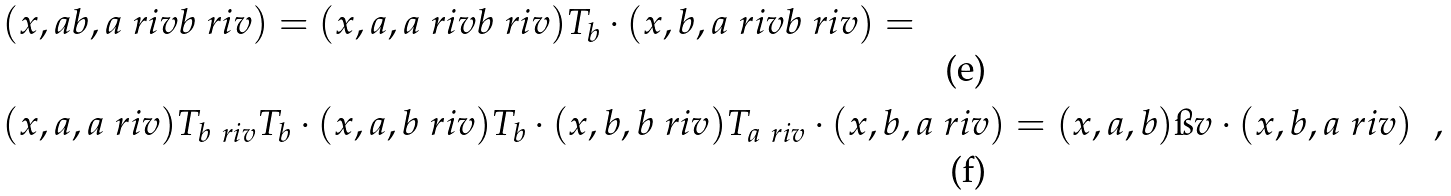Convert formula to latex. <formula><loc_0><loc_0><loc_500><loc_500>& ( x , a b , a \ r i v b \ r i v ) = ( x , a , a \ r i v b \ r i v ) T _ { b } \cdot ( x , b , a \ r i v b \ r i v ) = \\ & ( x , a , a \ r i v ) T _ { b \ r i v } T _ { b } \cdot ( x , a , b \ r i v ) T _ { b } \cdot ( x , b , b \ r i v ) T _ { a \ r i v } \cdot ( x , b , a \ r i v ) = ( x , a , b ) \i v \cdot ( x , b , a \ r i v ) \ \ ,</formula> 